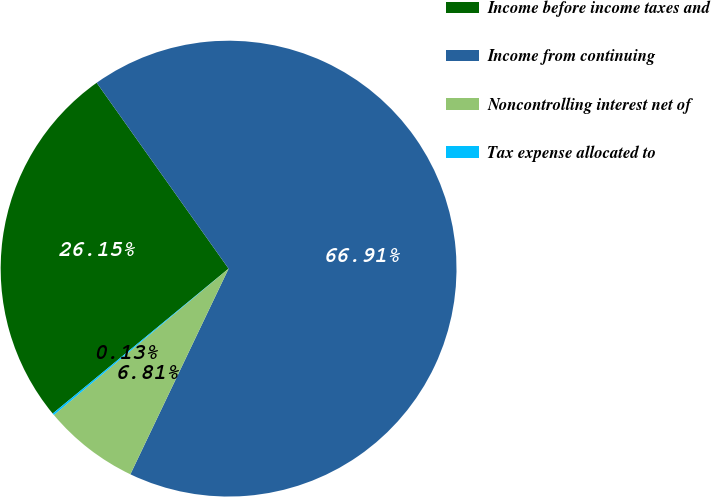Convert chart. <chart><loc_0><loc_0><loc_500><loc_500><pie_chart><fcel>Income before income taxes and<fcel>Income from continuing<fcel>Noncontrolling interest net of<fcel>Tax expense allocated to<nl><fcel>26.15%<fcel>66.92%<fcel>6.81%<fcel>0.13%<nl></chart> 